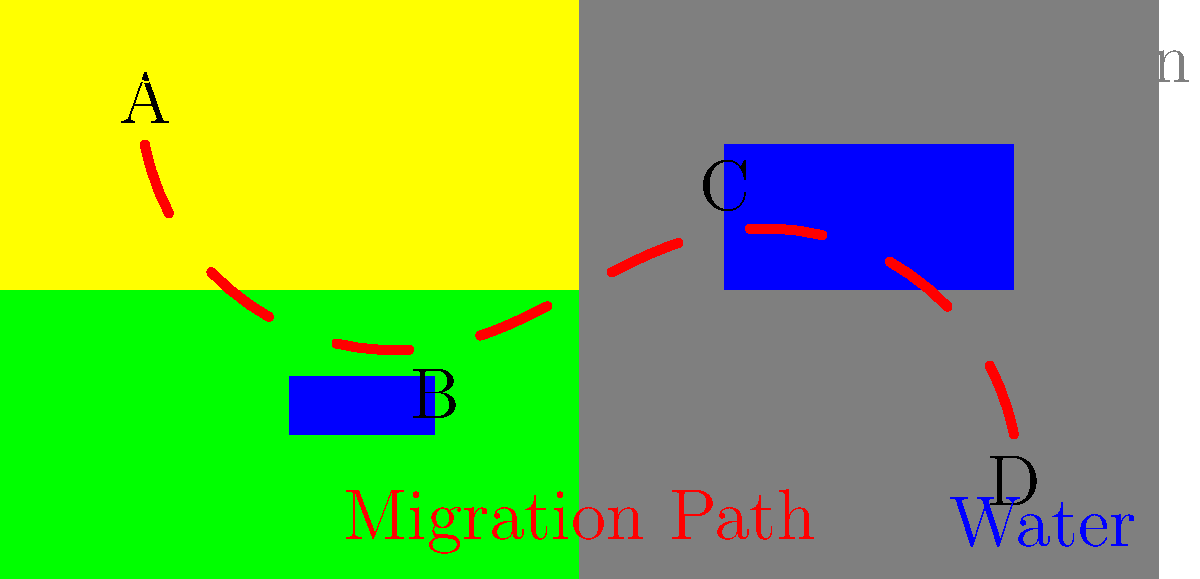As a biologist studying the impact of government policies on endangered species, you're tracking the migration pattern of a rare bird species across different terrains. The image shows the bird's path from point A to D, passing through points B and C. Which terrain type does the bird spend the least time in during its migration, and how might this affect conservation policies? To answer this question, we need to analyze the migration path and the terrains it crosses:

1. The bird starts at point A in the desert terrain.
2. It then moves to point B, crossing a small body of water in the forest terrain.
3. From B to C, it moves through the desert and into the mountainous region.
4. Finally, it ends at point D, still in the mountainous area but near a larger body of water.

Looking at the path:
- Desert: Crossed twice (start and middle)
- Forest: Briefly at the beginning
- Mountain: Crossed in the latter half of the journey
- Water: Passed near two bodies but not directly through

The terrain the bird spends the least time in is clearly the forest. It only briefly passes through the forest at the beginning of its journey.

This observation can affect conservation policies in several ways:
1. Limited forest exposure might indicate that the species doesn't rely heavily on forest habitats, which could influence habitat protection priorities.
2. The brief forest transit might be a crucial rest stop, emphasizing the need to protect even small forest patches along migration routes.
3. Conservation efforts might need to focus more on protecting desert and mountain habitats, as well as water sources, which seem more significant for this species' migration.
4. Policies might need to address the connectivity between different terrain types to ensure safe passage for the migrating birds.
Answer: Forest; may shift focus to desert/mountain conservation and habitat connectivity 